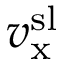Convert formula to latex. <formula><loc_0><loc_0><loc_500><loc_500>v _ { x } ^ { s l }</formula> 